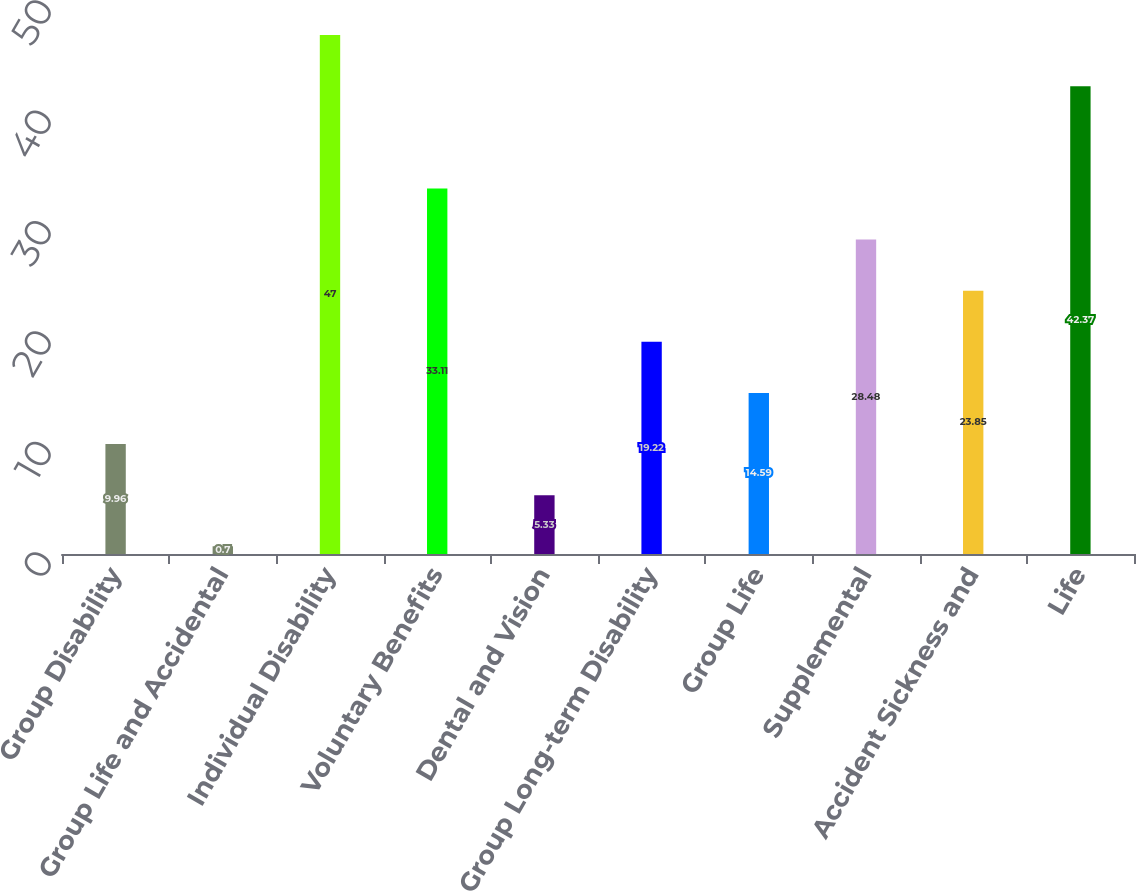Convert chart to OTSL. <chart><loc_0><loc_0><loc_500><loc_500><bar_chart><fcel>Group Disability<fcel>Group Life and Accidental<fcel>Individual Disability<fcel>Voluntary Benefits<fcel>Dental and Vision<fcel>Group Long-term Disability<fcel>Group Life<fcel>Supplemental<fcel>Accident Sickness and<fcel>Life<nl><fcel>9.96<fcel>0.7<fcel>47<fcel>33.11<fcel>5.33<fcel>19.22<fcel>14.59<fcel>28.48<fcel>23.85<fcel>42.37<nl></chart> 